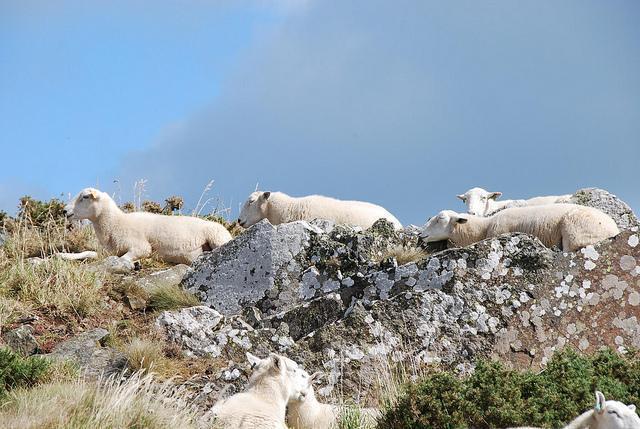How many sheep are in the photo?
Give a very brief answer. 5. 